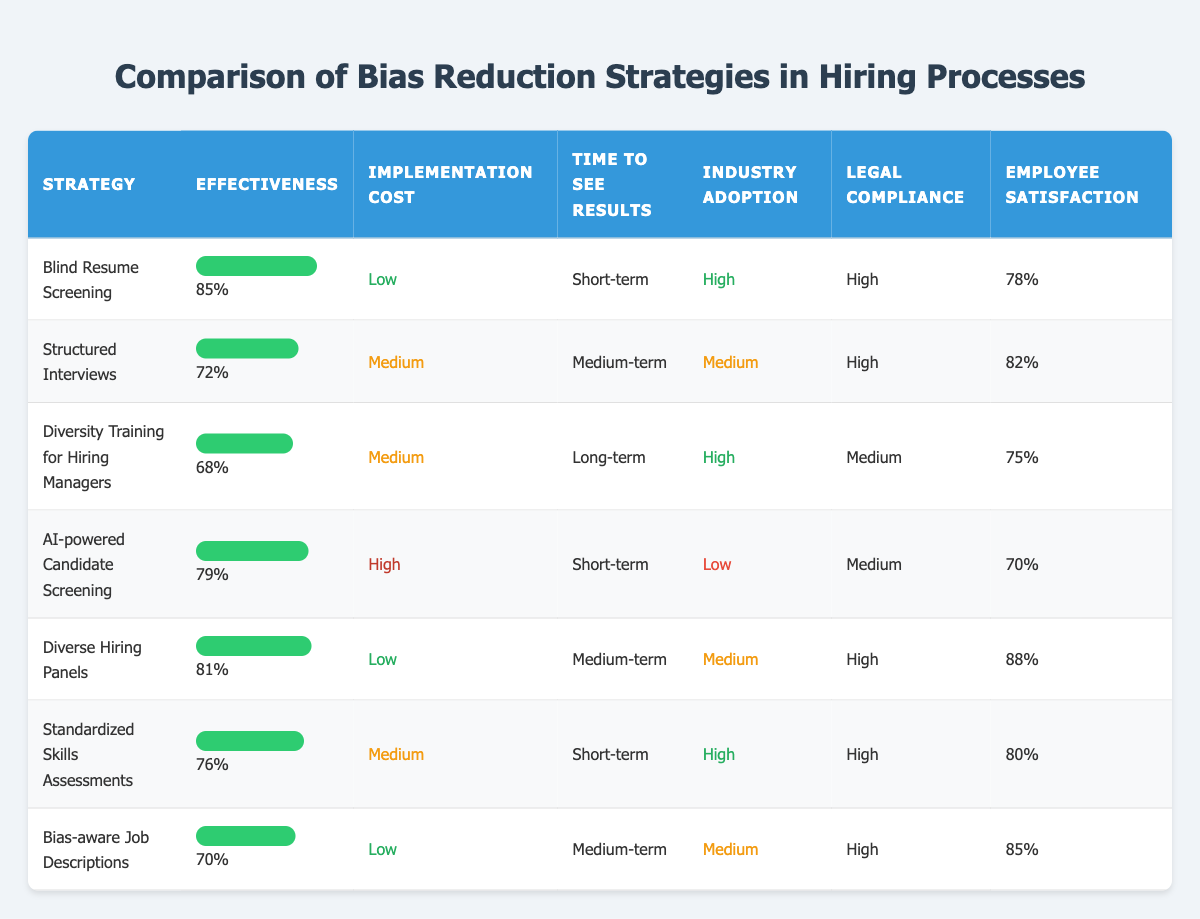What is the effectiveness percentage of Blind Resume Screening? The table lists Blind Resume Screening with an effectiveness of 85%. This can be directly retrieved from the table without further calculations.
Answer: 85% Which strategy has the highest employee satisfaction? By examining the employee satisfaction column, Diverse Hiring Panels has the highest score at 88%. This is straightforward as it is the maximum value in that column.
Answer: 88% Is the implementation cost of AI-powered Candidate Screening low? The implementation cost listed for AI-powered Candidate Screening is high. Hence, the answer to whether it is low is no.
Answer: No What is the average effectiveness of the strategies that have high industry adoption? The strategies with high industry adoption are Blind Resume Screening, Diversity Training for Hiring Managers, Standardized Skills Assessments, and Diverse Hiring Panels. Their effectiveness scores (85, 68, 76, 81) can be summed up to 310. Since there are four strategies, the average is 310/4 = 77.5.
Answer: 77.5 Which strategies have medium-term time to see results? Looking at the time to see results column, the strategies listed for medium-term are Structured Interviews, Diverse Hiring Panels, and Bias-aware Job Descriptions. These can be identified directly by checking this column for the medium-term label.
Answer: Structured Interviews, Diverse Hiring Panels, Bias-aware Job Descriptions How many strategies have both high legal compliance and low implementation cost? The strategies that fulfill both criteria are Blind Resume Screening and Diverse Hiring Panels. This involves checking each strategy against both columns and finding the matches. Hence, there are 2 strategies that meet the criteria.
Answer: 2 Do all strategies with high effectiveness also have high industry adoption? The table reveals that while Blind Resume Screening (85% effectiveness) and Standardized Skills Assessments (76% effectiveness) have high industry adoption, AI-powered Candidate Screening (79% effectiveness) has low industry adoption. Therefore, the answer is no.
Answer: No What is the difference in effectiveness between the strategy with the highest and the one with the lowest scores? Blind Resume Screening has the highest effectiveness at 85%, while Diversity Training for Hiring Managers has the lowest at 68%. The difference is calculated as 85 - 68 = 17.
Answer: 17 Which strategy has the lowest employee satisfaction among those with a medium implementation cost? Among the strategies with a medium implementation cost, the employee satisfaction scores are 82% for Structured Interviews, 75% for Diversity Training for Hiring Managers, and 80% for Standardized Skills Assessments. Therefore, the lowest is found in Diversity Training for Hiring Managers at 75%.
Answer: 75% 